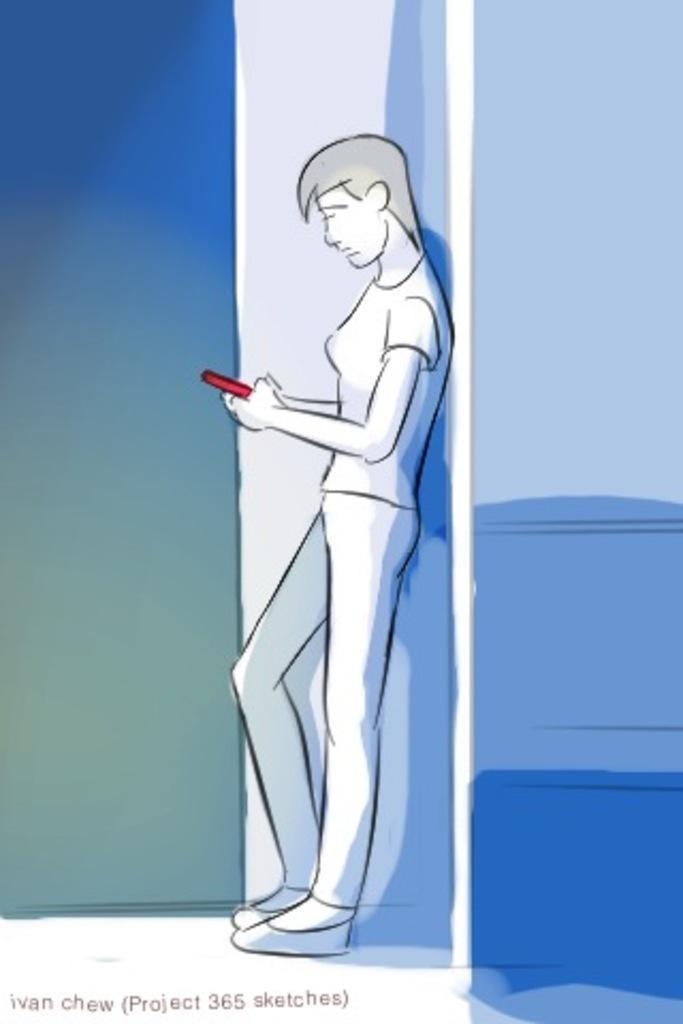How would you summarize this image in a sentence or two? This is the drawing of a person leaning on a wall and holding a red mobile phone. 